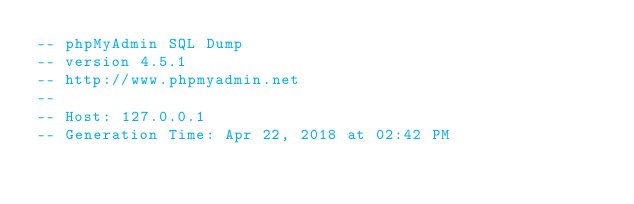Convert code to text. <code><loc_0><loc_0><loc_500><loc_500><_SQL_>-- phpMyAdmin SQL Dump
-- version 4.5.1
-- http://www.phpmyadmin.net
--
-- Host: 127.0.0.1
-- Generation Time: Apr 22, 2018 at 02:42 PM</code> 